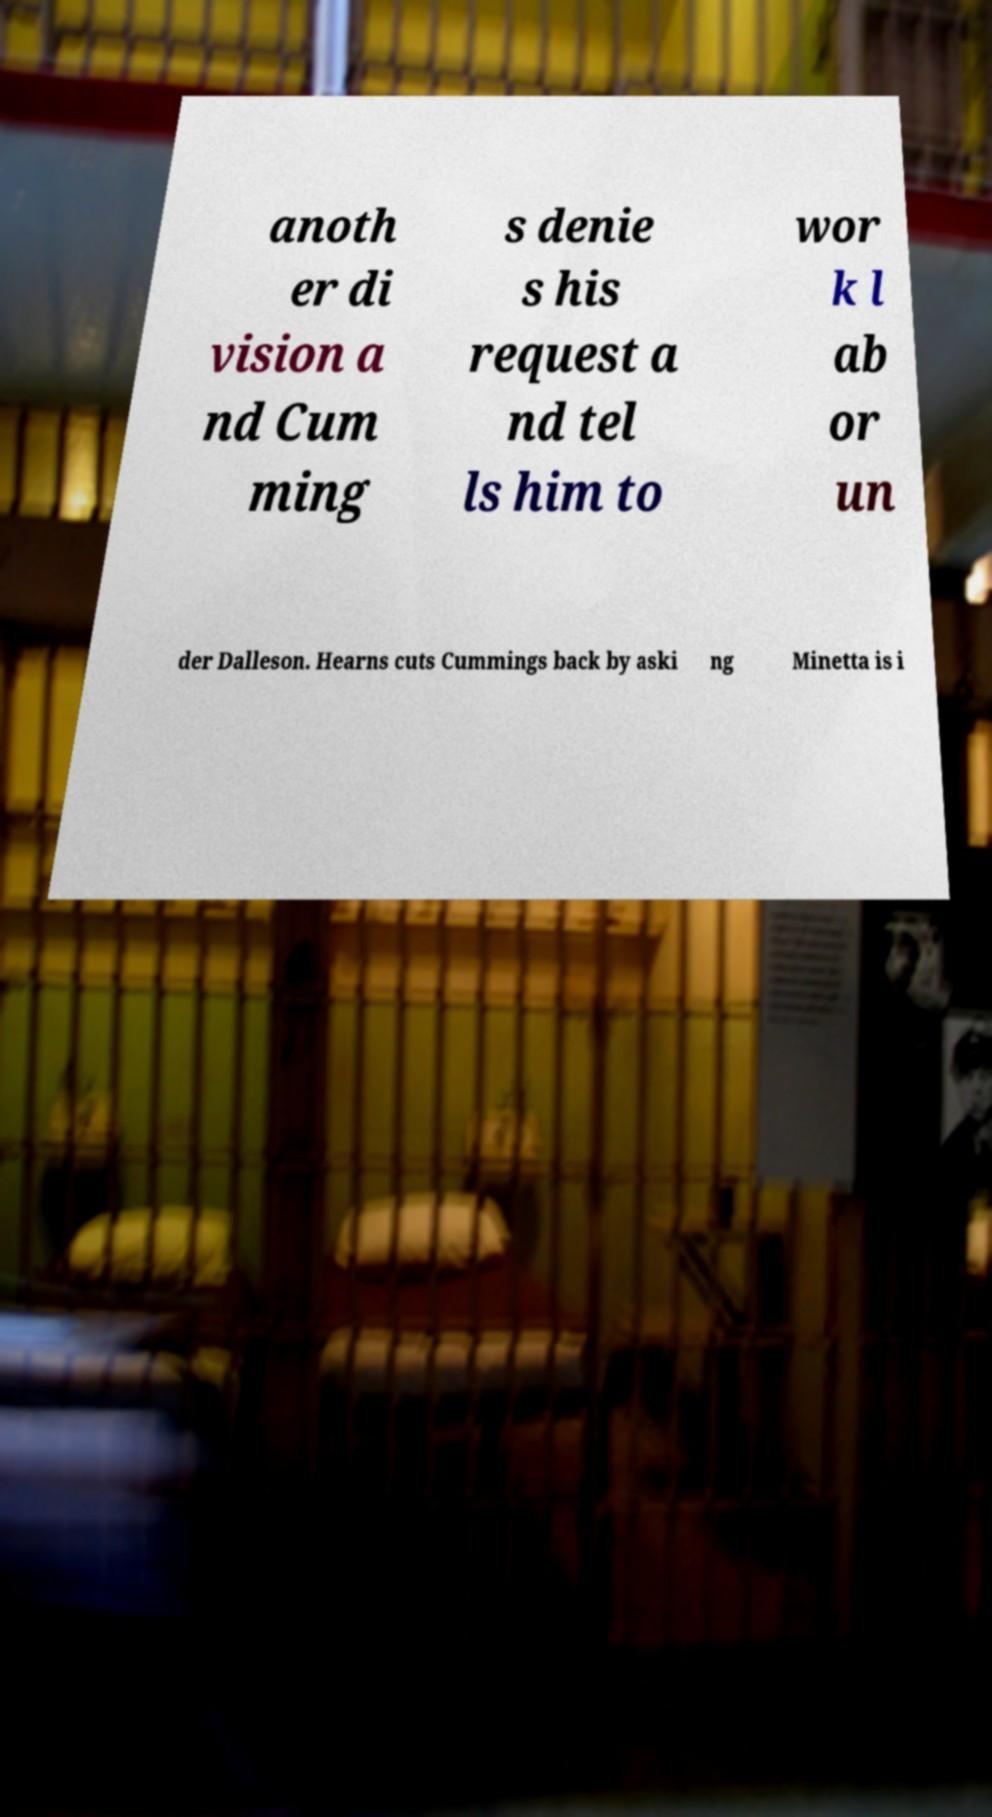I need the written content from this picture converted into text. Can you do that? anoth er di vision a nd Cum ming s denie s his request a nd tel ls him to wor k l ab or un der Dalleson. Hearns cuts Cummings back by aski ng Minetta is i 